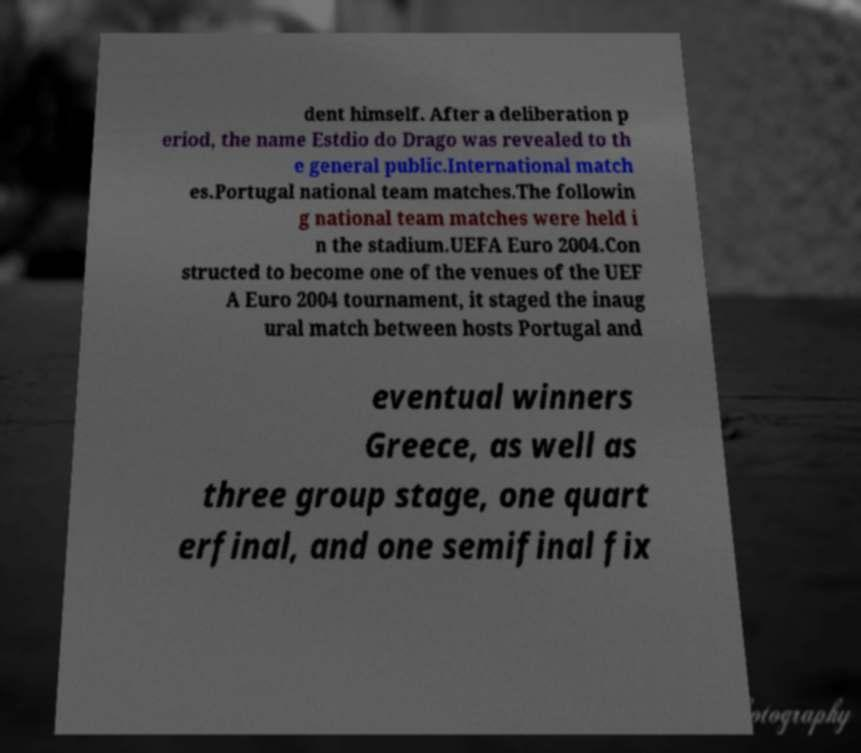Please identify and transcribe the text found in this image. dent himself. After a deliberation p eriod, the name Estdio do Drago was revealed to th e general public.International match es.Portugal national team matches.The followin g national team matches were held i n the stadium.UEFA Euro 2004.Con structed to become one of the venues of the UEF A Euro 2004 tournament, it staged the inaug ural match between hosts Portugal and eventual winners Greece, as well as three group stage, one quart erfinal, and one semifinal fix 